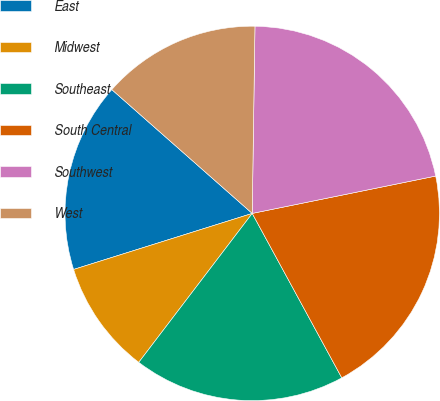Convert chart to OTSL. <chart><loc_0><loc_0><loc_500><loc_500><pie_chart><fcel>East<fcel>Midwest<fcel>Southeast<fcel>South Central<fcel>Southwest<fcel>West<nl><fcel>16.34%<fcel>9.8%<fcel>18.3%<fcel>20.26%<fcel>21.57%<fcel>13.73%<nl></chart> 